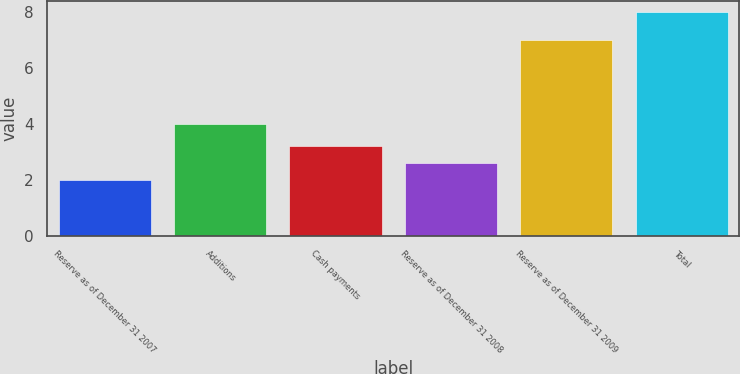Convert chart. <chart><loc_0><loc_0><loc_500><loc_500><bar_chart><fcel>Reserve as of December 31 2007<fcel>Additions<fcel>Cash payments<fcel>Reserve as of December 31 2008<fcel>Reserve as of December 31 2009<fcel>Total<nl><fcel>2<fcel>4<fcel>3.2<fcel>2.6<fcel>7<fcel>8<nl></chart> 